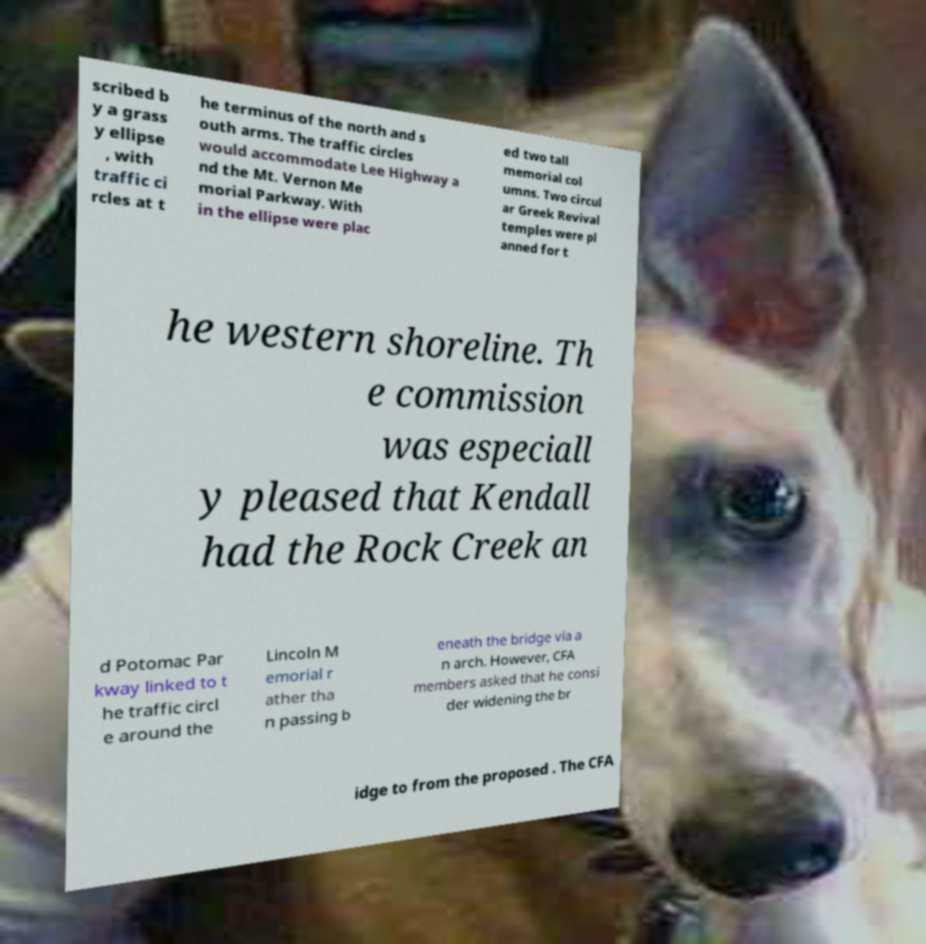There's text embedded in this image that I need extracted. Can you transcribe it verbatim? scribed b y a grass y ellipse , with traffic ci rcles at t he terminus of the north and s outh arms. The traffic circles would accommodate Lee Highway a nd the Mt. Vernon Me morial Parkway. With in the ellipse were plac ed two tall memorial col umns. Two circul ar Greek Revival temples were pl anned for t he western shoreline. Th e commission was especiall y pleased that Kendall had the Rock Creek an d Potomac Par kway linked to t he traffic circl e around the Lincoln M emorial r ather tha n passing b eneath the bridge via a n arch. However, CFA members asked that he consi der widening the br idge to from the proposed . The CFA 